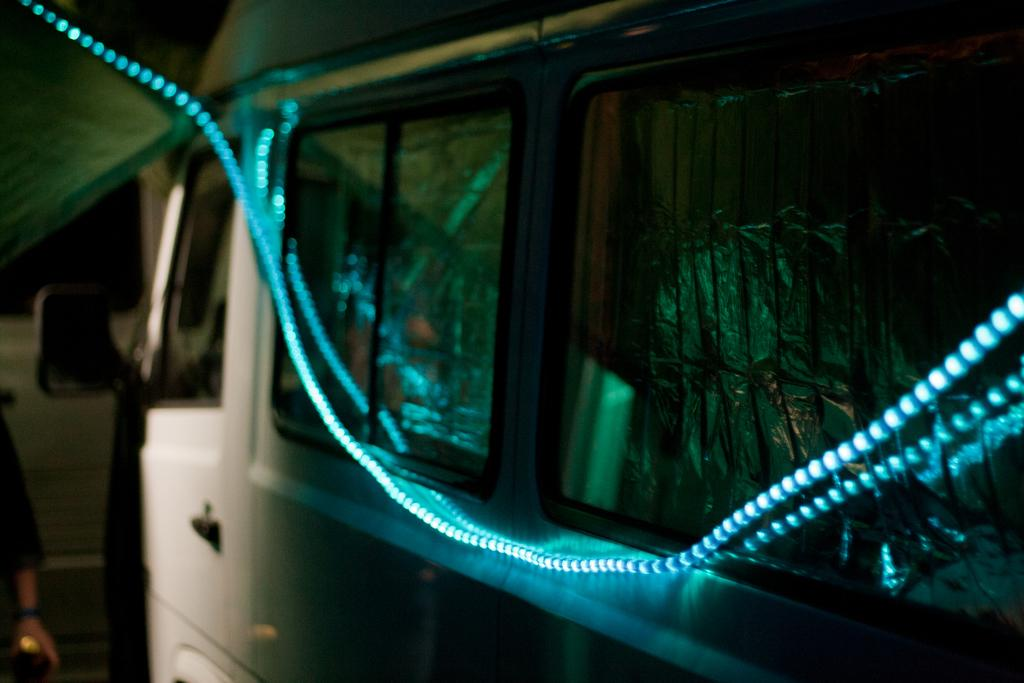What types of objects are present in the image? There are vehicles and lights visible in the image. Can you describe the person in the image? There is a person holding an object in the image. What type of thread is being used by the person in the image? There is no thread present in the image; the person is holding an object, but it is not specified as thread. 